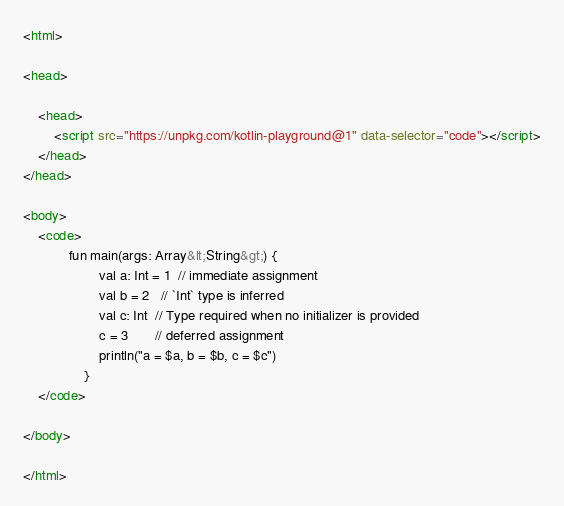<code> <loc_0><loc_0><loc_500><loc_500><_HTML_><html>

<head>

    <head>
        <script src="https://unpkg.com/kotlin-playground@1" data-selector="code"></script>
    </head>
</head>

<body>
    <code>
            fun main(args: Array&lt;String&gt;) {
                    val a: Int = 1  // immediate assignment
                    val b = 2   // `Int` type is inferred
                    val c: Int  // Type required when no initializer is provided
                    c = 3       // deferred assignment
                    println("a = $a, b = $b, c = $c")
                }
    </code>

</body>

</html>
</code> 